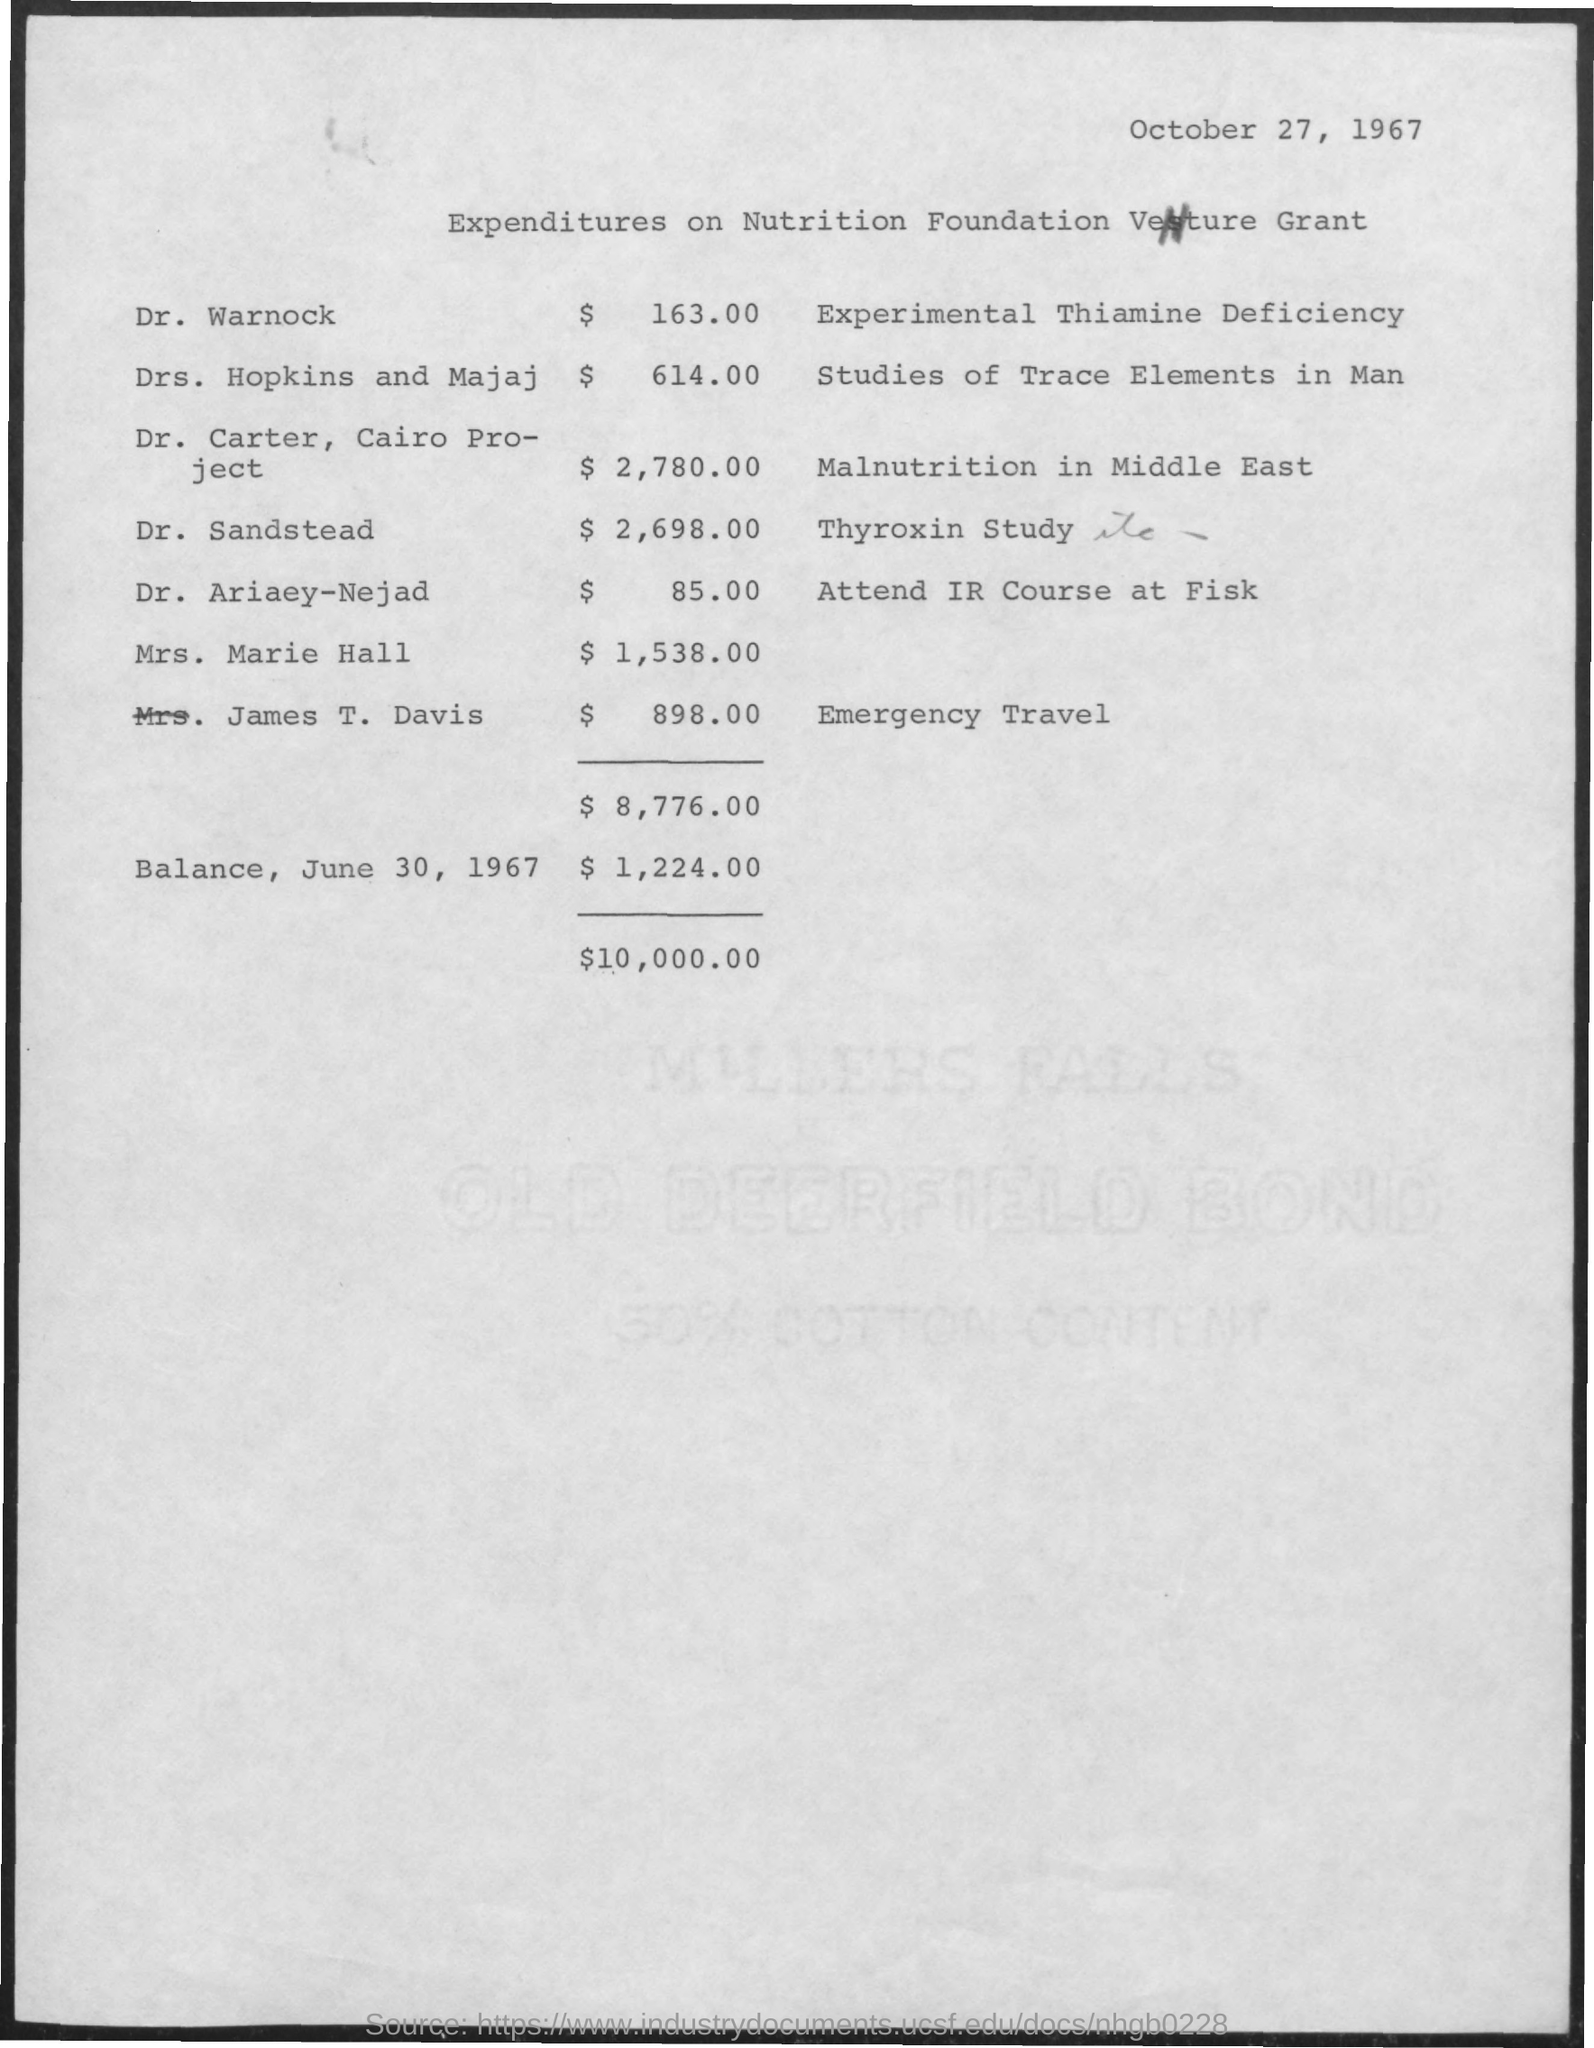What is the date on the document?
Provide a short and direct response. October 27, 1967. What is the amount for Dr. Warnock?
Offer a very short reply. $ 163.00. What is the amount for Drs. Hopkin and Majaj?
Your answer should be compact. $ 614.00. What is the amount for Dr. Carter, Cairo Project?
Give a very brief answer. $2,780.00. What is the amount for Dr. Sandstead?
Your answer should be compact. $ 2,698.00. What is the amount for Dr. Ariaey-Nejad?
Give a very brief answer. $ 85.00. What is the amount for Mrs. Marie Hall?
Ensure brevity in your answer.  $ 1,538. What is the amount for James T. Davis?
Provide a short and direct response. $ 898.00. What is the Balance, June 30, 1967?
Offer a very short reply. $ 1,224.00. 